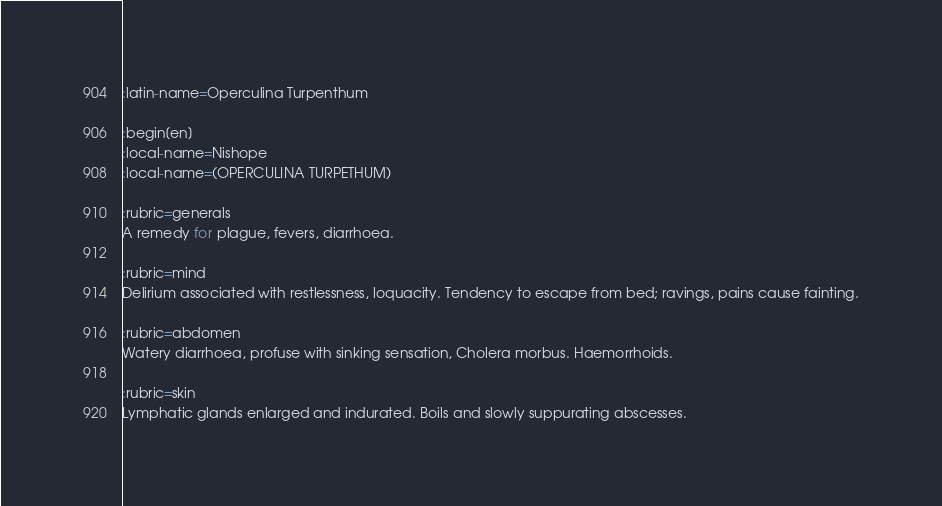<code> <loc_0><loc_0><loc_500><loc_500><_ObjectiveC_>:latin-name=Operculina Turpenthum

:begin[en]
:local-name=Nishope
:local-name=(OPERCULINA TURPETHUM)

:rubric=generals
A remedy for plague, fevers, diarrhoea.

:rubric=mind
Delirium associated with restlessness, loquacity. Tendency to escape from bed; ravings, pains cause fainting.

:rubric=abdomen
Watery diarrhoea, profuse with sinking sensation, Cholera morbus. Haemorrhoids.

:rubric=skin
Lymphatic glands enlarged and indurated. Boils and slowly suppurating abscesses.

</code> 